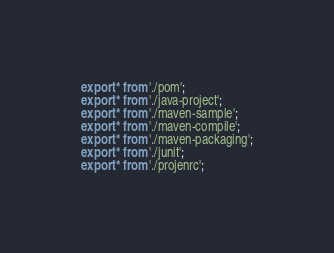Convert code to text. <code><loc_0><loc_0><loc_500><loc_500><_TypeScript_>export * from './pom';
export * from './java-project';
export * from './maven-sample';
export * from './maven-compile';
export * from './maven-packaging';
export * from './junit';
export * from './projenrc';
</code> 